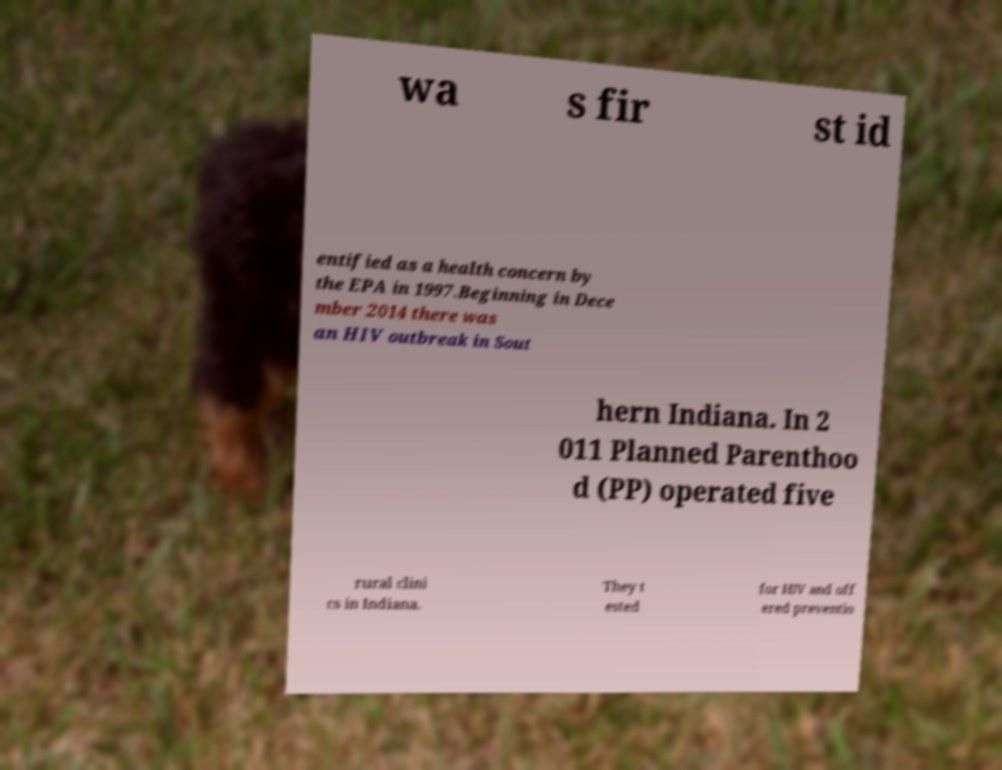For documentation purposes, I need the text within this image transcribed. Could you provide that? wa s fir st id entified as a health concern by the EPA in 1997.Beginning in Dece mber 2014 there was an HIV outbreak in Sout hern Indiana. In 2 011 Planned Parenthoo d (PP) operated five rural clini cs in Indiana. They t ested for HIV and off ered preventio 